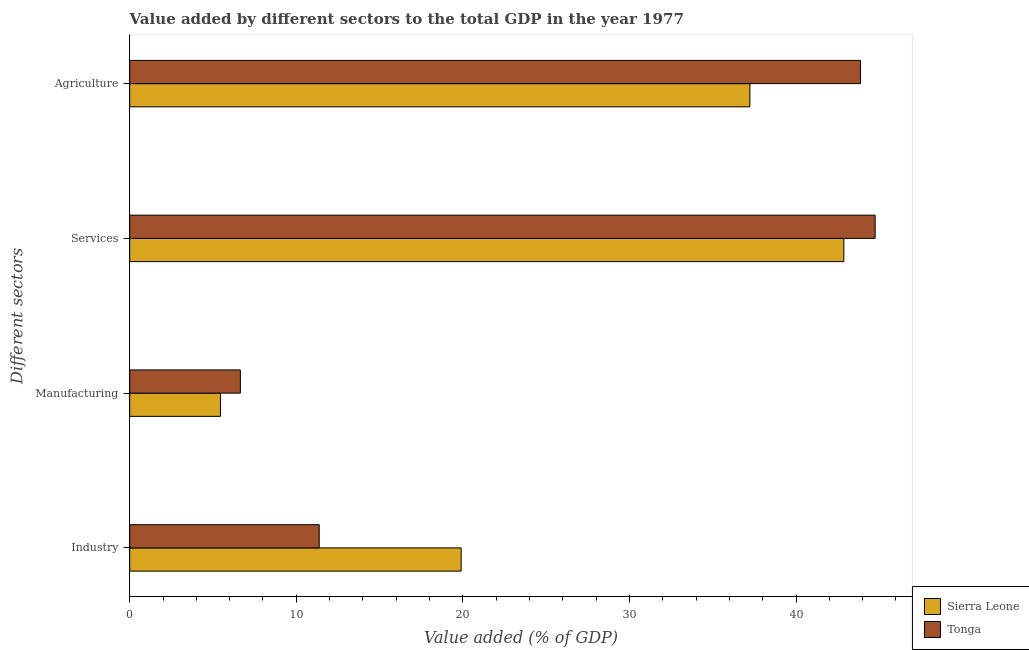How many groups of bars are there?
Make the answer very short. 4. Are the number of bars per tick equal to the number of legend labels?
Provide a short and direct response. Yes. Are the number of bars on each tick of the Y-axis equal?
Offer a very short reply. Yes. How many bars are there on the 2nd tick from the top?
Offer a very short reply. 2. What is the label of the 4th group of bars from the top?
Your response must be concise. Industry. What is the value added by agricultural sector in Sierra Leone?
Provide a succinct answer. 37.23. Across all countries, what is the maximum value added by manufacturing sector?
Your response must be concise. 6.64. Across all countries, what is the minimum value added by services sector?
Provide a short and direct response. 42.87. In which country was the value added by services sector maximum?
Your answer should be compact. Tonga. In which country was the value added by agricultural sector minimum?
Make the answer very short. Sierra Leone. What is the total value added by services sector in the graph?
Provide a succinct answer. 87.62. What is the difference between the value added by industrial sector in Tonga and that in Sierra Leone?
Provide a succinct answer. -8.52. What is the difference between the value added by agricultural sector in Sierra Leone and the value added by industrial sector in Tonga?
Your answer should be compact. 25.86. What is the average value added by services sector per country?
Offer a terse response. 43.81. What is the difference between the value added by agricultural sector and value added by industrial sector in Tonga?
Offer a terse response. 32.5. What is the ratio of the value added by manufacturing sector in Sierra Leone to that in Tonga?
Provide a short and direct response. 0.82. Is the difference between the value added by manufacturing sector in Sierra Leone and Tonga greater than the difference between the value added by services sector in Sierra Leone and Tonga?
Make the answer very short. Yes. What is the difference between the highest and the second highest value added by agricultural sector?
Make the answer very short. 6.64. What is the difference between the highest and the lowest value added by agricultural sector?
Provide a short and direct response. 6.64. In how many countries, is the value added by services sector greater than the average value added by services sector taken over all countries?
Your answer should be compact. 1. Is the sum of the value added by agricultural sector in Tonga and Sierra Leone greater than the maximum value added by industrial sector across all countries?
Provide a succinct answer. Yes. Is it the case that in every country, the sum of the value added by services sector and value added by industrial sector is greater than the sum of value added by manufacturing sector and value added by agricultural sector?
Provide a succinct answer. No. What does the 1st bar from the top in Industry represents?
Ensure brevity in your answer.  Tonga. What does the 2nd bar from the bottom in Agriculture represents?
Give a very brief answer. Tonga. Is it the case that in every country, the sum of the value added by industrial sector and value added by manufacturing sector is greater than the value added by services sector?
Keep it short and to the point. No. Are all the bars in the graph horizontal?
Keep it short and to the point. Yes. How many countries are there in the graph?
Offer a terse response. 2. What is the difference between two consecutive major ticks on the X-axis?
Provide a succinct answer. 10. Are the values on the major ticks of X-axis written in scientific E-notation?
Provide a short and direct response. No. Does the graph contain grids?
Your answer should be compact. No. Where does the legend appear in the graph?
Your answer should be very brief. Bottom right. How many legend labels are there?
Ensure brevity in your answer.  2. What is the title of the graph?
Your answer should be very brief. Value added by different sectors to the total GDP in the year 1977. What is the label or title of the X-axis?
Ensure brevity in your answer.  Value added (% of GDP). What is the label or title of the Y-axis?
Offer a terse response. Different sectors. What is the Value added (% of GDP) of Sierra Leone in Industry?
Provide a short and direct response. 19.9. What is the Value added (% of GDP) in Tonga in Industry?
Your answer should be very brief. 11.38. What is the Value added (% of GDP) of Sierra Leone in Manufacturing?
Offer a very short reply. 5.45. What is the Value added (% of GDP) in Tonga in Manufacturing?
Give a very brief answer. 6.64. What is the Value added (% of GDP) of Sierra Leone in Services?
Your response must be concise. 42.87. What is the Value added (% of GDP) of Tonga in Services?
Your response must be concise. 44.75. What is the Value added (% of GDP) of Sierra Leone in Agriculture?
Your answer should be very brief. 37.23. What is the Value added (% of GDP) of Tonga in Agriculture?
Give a very brief answer. 43.87. Across all Different sectors, what is the maximum Value added (% of GDP) of Sierra Leone?
Keep it short and to the point. 42.87. Across all Different sectors, what is the maximum Value added (% of GDP) of Tonga?
Make the answer very short. 44.75. Across all Different sectors, what is the minimum Value added (% of GDP) of Sierra Leone?
Keep it short and to the point. 5.45. Across all Different sectors, what is the minimum Value added (% of GDP) of Tonga?
Keep it short and to the point. 6.64. What is the total Value added (% of GDP) of Sierra Leone in the graph?
Ensure brevity in your answer.  105.45. What is the total Value added (% of GDP) in Tonga in the graph?
Your answer should be very brief. 106.64. What is the difference between the Value added (% of GDP) in Sierra Leone in Industry and that in Manufacturing?
Make the answer very short. 14.45. What is the difference between the Value added (% of GDP) of Tonga in Industry and that in Manufacturing?
Make the answer very short. 4.73. What is the difference between the Value added (% of GDP) in Sierra Leone in Industry and that in Services?
Offer a terse response. -22.97. What is the difference between the Value added (% of GDP) in Tonga in Industry and that in Services?
Offer a terse response. -33.38. What is the difference between the Value added (% of GDP) of Sierra Leone in Industry and that in Agriculture?
Offer a terse response. -17.34. What is the difference between the Value added (% of GDP) in Tonga in Industry and that in Agriculture?
Keep it short and to the point. -32.5. What is the difference between the Value added (% of GDP) of Sierra Leone in Manufacturing and that in Services?
Make the answer very short. -37.42. What is the difference between the Value added (% of GDP) of Tonga in Manufacturing and that in Services?
Keep it short and to the point. -38.11. What is the difference between the Value added (% of GDP) of Sierra Leone in Manufacturing and that in Agriculture?
Give a very brief answer. -31.78. What is the difference between the Value added (% of GDP) of Tonga in Manufacturing and that in Agriculture?
Offer a very short reply. -37.23. What is the difference between the Value added (% of GDP) in Sierra Leone in Services and that in Agriculture?
Ensure brevity in your answer.  5.64. What is the difference between the Value added (% of GDP) in Tonga in Services and that in Agriculture?
Your response must be concise. 0.88. What is the difference between the Value added (% of GDP) of Sierra Leone in Industry and the Value added (% of GDP) of Tonga in Manufacturing?
Your response must be concise. 13.26. What is the difference between the Value added (% of GDP) of Sierra Leone in Industry and the Value added (% of GDP) of Tonga in Services?
Offer a very short reply. -24.85. What is the difference between the Value added (% of GDP) in Sierra Leone in Industry and the Value added (% of GDP) in Tonga in Agriculture?
Offer a terse response. -23.98. What is the difference between the Value added (% of GDP) of Sierra Leone in Manufacturing and the Value added (% of GDP) of Tonga in Services?
Your response must be concise. -39.3. What is the difference between the Value added (% of GDP) in Sierra Leone in Manufacturing and the Value added (% of GDP) in Tonga in Agriculture?
Make the answer very short. -38.42. What is the difference between the Value added (% of GDP) of Sierra Leone in Services and the Value added (% of GDP) of Tonga in Agriculture?
Your answer should be very brief. -1. What is the average Value added (% of GDP) of Sierra Leone per Different sectors?
Ensure brevity in your answer.  26.36. What is the average Value added (% of GDP) in Tonga per Different sectors?
Give a very brief answer. 26.66. What is the difference between the Value added (% of GDP) in Sierra Leone and Value added (% of GDP) in Tonga in Industry?
Your response must be concise. 8.52. What is the difference between the Value added (% of GDP) of Sierra Leone and Value added (% of GDP) of Tonga in Manufacturing?
Keep it short and to the point. -1.19. What is the difference between the Value added (% of GDP) in Sierra Leone and Value added (% of GDP) in Tonga in Services?
Provide a succinct answer. -1.88. What is the difference between the Value added (% of GDP) of Sierra Leone and Value added (% of GDP) of Tonga in Agriculture?
Your answer should be very brief. -6.64. What is the ratio of the Value added (% of GDP) of Sierra Leone in Industry to that in Manufacturing?
Your answer should be very brief. 3.65. What is the ratio of the Value added (% of GDP) in Tonga in Industry to that in Manufacturing?
Offer a very short reply. 1.71. What is the ratio of the Value added (% of GDP) of Sierra Leone in Industry to that in Services?
Give a very brief answer. 0.46. What is the ratio of the Value added (% of GDP) of Tonga in Industry to that in Services?
Make the answer very short. 0.25. What is the ratio of the Value added (% of GDP) of Sierra Leone in Industry to that in Agriculture?
Keep it short and to the point. 0.53. What is the ratio of the Value added (% of GDP) of Tonga in Industry to that in Agriculture?
Your answer should be compact. 0.26. What is the ratio of the Value added (% of GDP) of Sierra Leone in Manufacturing to that in Services?
Your response must be concise. 0.13. What is the ratio of the Value added (% of GDP) of Tonga in Manufacturing to that in Services?
Your answer should be very brief. 0.15. What is the ratio of the Value added (% of GDP) of Sierra Leone in Manufacturing to that in Agriculture?
Your response must be concise. 0.15. What is the ratio of the Value added (% of GDP) in Tonga in Manufacturing to that in Agriculture?
Offer a terse response. 0.15. What is the ratio of the Value added (% of GDP) in Sierra Leone in Services to that in Agriculture?
Provide a succinct answer. 1.15. What is the difference between the highest and the second highest Value added (% of GDP) of Sierra Leone?
Offer a very short reply. 5.64. What is the difference between the highest and the second highest Value added (% of GDP) of Tonga?
Your answer should be compact. 0.88. What is the difference between the highest and the lowest Value added (% of GDP) in Sierra Leone?
Your response must be concise. 37.42. What is the difference between the highest and the lowest Value added (% of GDP) of Tonga?
Your answer should be compact. 38.11. 